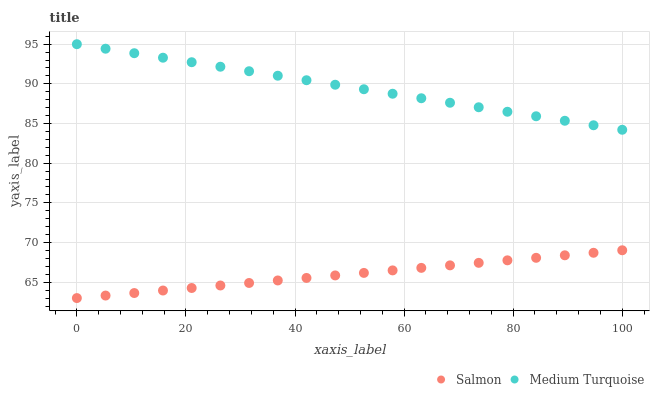Does Salmon have the minimum area under the curve?
Answer yes or no. Yes. Does Medium Turquoise have the maximum area under the curve?
Answer yes or no. Yes. Does Medium Turquoise have the minimum area under the curve?
Answer yes or no. No. Is Medium Turquoise the smoothest?
Answer yes or no. Yes. Is Salmon the roughest?
Answer yes or no. Yes. Is Medium Turquoise the roughest?
Answer yes or no. No. Does Salmon have the lowest value?
Answer yes or no. Yes. Does Medium Turquoise have the lowest value?
Answer yes or no. No. Does Medium Turquoise have the highest value?
Answer yes or no. Yes. Is Salmon less than Medium Turquoise?
Answer yes or no. Yes. Is Medium Turquoise greater than Salmon?
Answer yes or no. Yes. Does Salmon intersect Medium Turquoise?
Answer yes or no. No. 